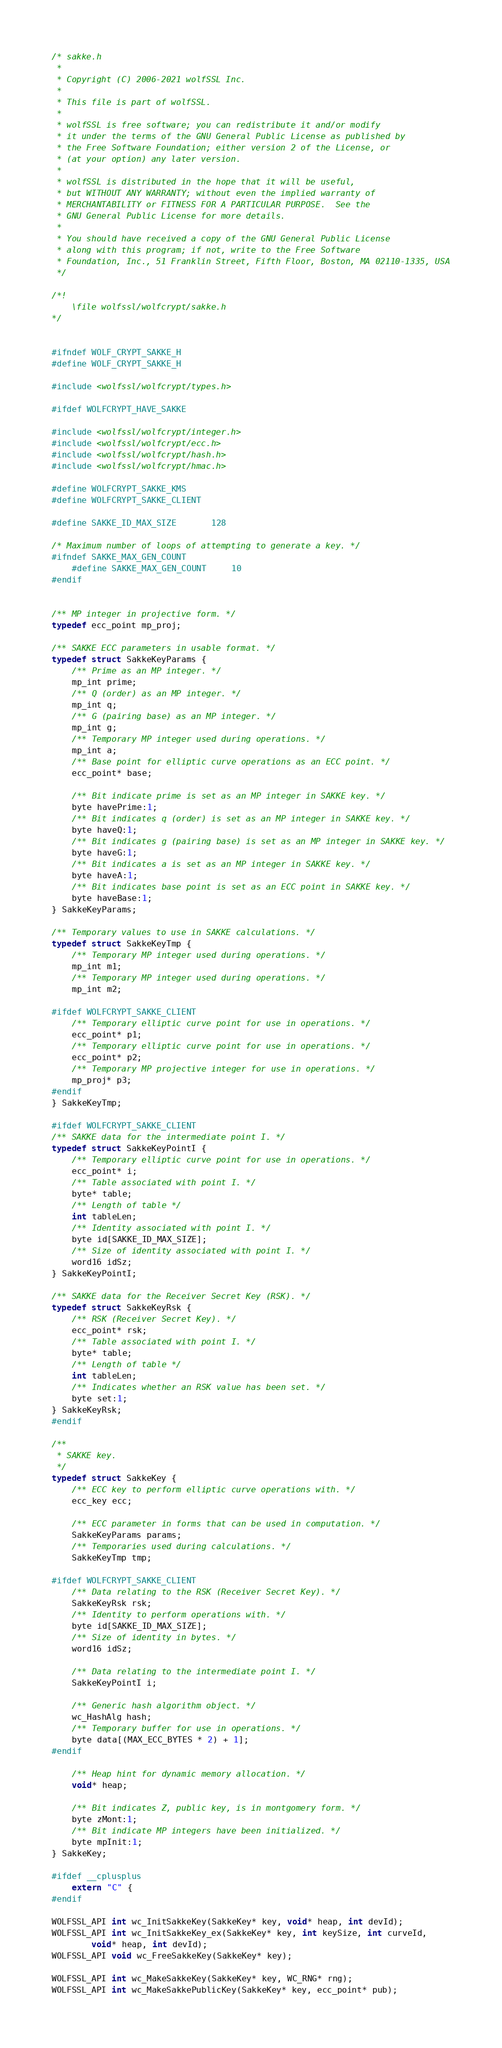Convert code to text. <code><loc_0><loc_0><loc_500><loc_500><_C_>/* sakke.h
 *
 * Copyright (C) 2006-2021 wolfSSL Inc.
 *
 * This file is part of wolfSSL.
 *
 * wolfSSL is free software; you can redistribute it and/or modify
 * it under the terms of the GNU General Public License as published by
 * the Free Software Foundation; either version 2 of the License, or
 * (at your option) any later version.
 *
 * wolfSSL is distributed in the hope that it will be useful,
 * but WITHOUT ANY WARRANTY; without even the implied warranty of
 * MERCHANTABILITY or FITNESS FOR A PARTICULAR PURPOSE.  See the
 * GNU General Public License for more details.
 *
 * You should have received a copy of the GNU General Public License
 * along with this program; if not, write to the Free Software
 * Foundation, Inc., 51 Franklin Street, Fifth Floor, Boston, MA 02110-1335, USA
 */

/*!
    \file wolfssl/wolfcrypt/sakke.h
*/


#ifndef WOLF_CRYPT_SAKKE_H
#define WOLF_CRYPT_SAKKE_H

#include <wolfssl/wolfcrypt/types.h>

#ifdef WOLFCRYPT_HAVE_SAKKE

#include <wolfssl/wolfcrypt/integer.h>
#include <wolfssl/wolfcrypt/ecc.h>
#include <wolfssl/wolfcrypt/hash.h>
#include <wolfssl/wolfcrypt/hmac.h>

#define WOLFCRYPT_SAKKE_KMS
#define WOLFCRYPT_SAKKE_CLIENT

#define SAKKE_ID_MAX_SIZE       128

/* Maximum number of loops of attempting to generate a key. */
#ifndef SAKKE_MAX_GEN_COUNT
    #define SAKKE_MAX_GEN_COUNT     10
#endif


/** MP integer in projective form. */
typedef ecc_point mp_proj;

/** SAKKE ECC parameters in usable format. */
typedef struct SakkeKeyParams {
    /** Prime as an MP integer. */
    mp_int prime;
    /** Q (order) as an MP integer. */
    mp_int q;
    /** G (pairing base) as an MP integer. */
    mp_int g;
    /** Temporary MP integer used during operations. */
    mp_int a;
    /** Base point for elliptic curve operations as an ECC point. */
    ecc_point* base;

    /** Bit indicate prime is set as an MP integer in SAKKE key. */
    byte havePrime:1;
    /** Bit indicates q (order) is set as an MP integer in SAKKE key. */
    byte haveQ:1;
    /** Bit indicates g (pairing base) is set as an MP integer in SAKKE key. */
    byte haveG:1;
    /** Bit indicates a is set as an MP integer in SAKKE key. */
    byte haveA:1;
    /** Bit indicates base point is set as an ECC point in SAKKE key. */
    byte haveBase:1;
} SakkeKeyParams;

/** Temporary values to use in SAKKE calculations. */
typedef struct SakkeKeyTmp {
    /** Temporary MP integer used during operations. */
    mp_int m1;
    /** Temporary MP integer used during operations. */
    mp_int m2;

#ifdef WOLFCRYPT_SAKKE_CLIENT
    /** Temporary elliptic curve point for use in operations. */
    ecc_point* p1;
    /** Temporary elliptic curve point for use in operations. */
    ecc_point* p2;
    /** Temporary MP projective integer for use in operations. */
    mp_proj* p3;
#endif
} SakkeKeyTmp;

#ifdef WOLFCRYPT_SAKKE_CLIENT
/** SAKKE data for the intermediate point I. */
typedef struct SakkeKeyPointI {
    /** Temporary elliptic curve point for use in operations. */
    ecc_point* i;
    /** Table associated with point I. */
    byte* table;
    /** Length of table */
    int tableLen;
    /** Identity associated with point I. */
    byte id[SAKKE_ID_MAX_SIZE];
    /** Size of identity associated with point I. */
    word16 idSz;
} SakkeKeyPointI;

/** SAKKE data for the Receiver Secret Key (RSK). */
typedef struct SakkeKeyRsk {
    /** RSK (Receiver Secret Key). */
    ecc_point* rsk;
    /** Table associated with point I. */
    byte* table;
    /** Length of table */
    int tableLen;
    /** Indicates whether an RSK value has been set. */
    byte set:1;
} SakkeKeyRsk;
#endif

/**
 * SAKKE key.
 */
typedef struct SakkeKey {
    /** ECC key to perform elliptic curve operations with. */
    ecc_key ecc;

    /** ECC parameter in forms that can be used in computation. */
    SakkeKeyParams params;
    /** Temporaries used during calculations. */
    SakkeKeyTmp tmp;

#ifdef WOLFCRYPT_SAKKE_CLIENT
    /** Data relating to the RSK (Receiver Secret Key). */
    SakkeKeyRsk rsk;
    /** Identity to perform operations with. */
    byte id[SAKKE_ID_MAX_SIZE];
    /** Size of identity in bytes. */
    word16 idSz;

    /** Data relating to the intermediate point I. */
    SakkeKeyPointI i;

    /** Generic hash algorithm object. */
    wc_HashAlg hash;
    /** Temporary buffer for use in operations. */
    byte data[(MAX_ECC_BYTES * 2) + 1];
#endif

    /** Heap hint for dynamic memory allocation. */
    void* heap;

    /** Bit indicates Z, public key, is in montgomery form. */
    byte zMont:1;
    /** Bit indicate MP integers have been initialized. */
    byte mpInit:1;
} SakkeKey;

#ifdef __cplusplus
    extern "C" {
#endif

WOLFSSL_API int wc_InitSakkeKey(SakkeKey* key, void* heap, int devId);
WOLFSSL_API int wc_InitSakkeKey_ex(SakkeKey* key, int keySize, int curveId,
        void* heap, int devId);
WOLFSSL_API void wc_FreeSakkeKey(SakkeKey* key);

WOLFSSL_API int wc_MakeSakkeKey(SakkeKey* key, WC_RNG* rng);
WOLFSSL_API int wc_MakeSakkePublicKey(SakkeKey* key, ecc_point* pub);
</code> 